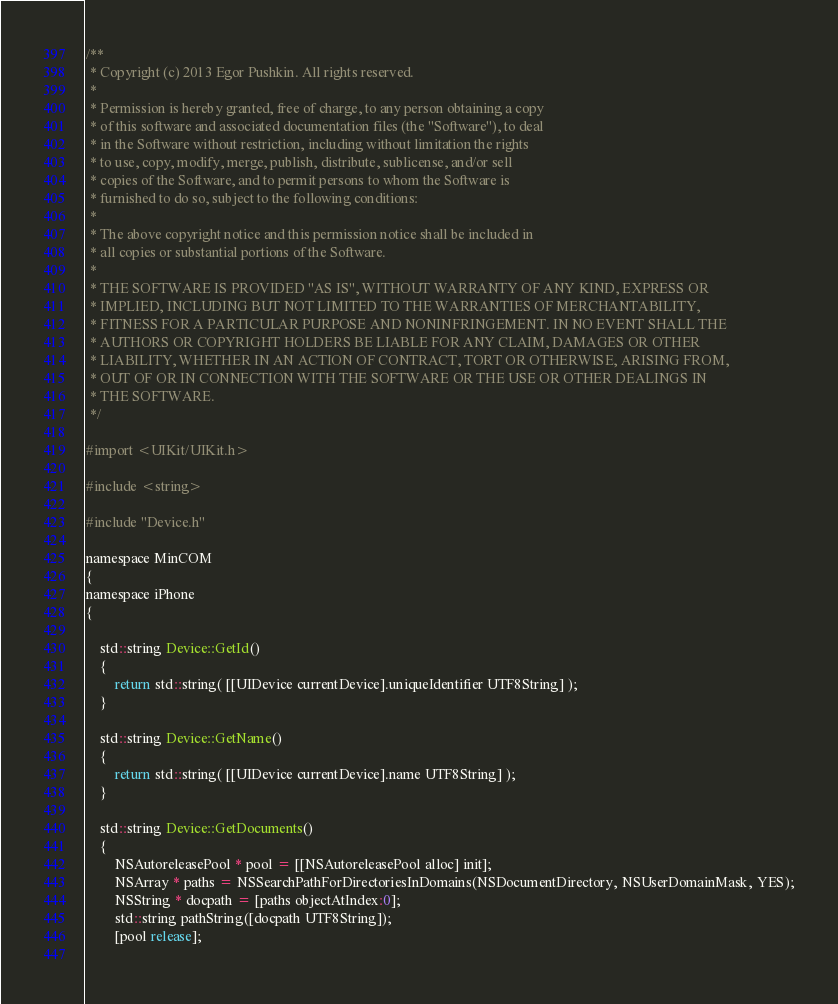Convert code to text. <code><loc_0><loc_0><loc_500><loc_500><_ObjectiveC_>/**
 * Copyright (c) 2013 Egor Pushkin. All rights reserved.
 * 
 * Permission is hereby granted, free of charge, to any person obtaining a copy
 * of this software and associated documentation files (the "Software"), to deal
 * in the Software without restriction, including without limitation the rights
 * to use, copy, modify, merge, publish, distribute, sublicense, and/or sell
 * copies of the Software, and to permit persons to whom the Software is
 * furnished to do so, subject to the following conditions:
 * 
 * The above copyright notice and this permission notice shall be included in
 * all copies or substantial portions of the Software.
 * 
 * THE SOFTWARE IS PROVIDED "AS IS", WITHOUT WARRANTY OF ANY KIND, EXPRESS OR
 * IMPLIED, INCLUDING BUT NOT LIMITED TO THE WARRANTIES OF MERCHANTABILITY,
 * FITNESS FOR A PARTICULAR PURPOSE AND NONINFRINGEMENT. IN NO EVENT SHALL THE
 * AUTHORS OR COPYRIGHT HOLDERS BE LIABLE FOR ANY CLAIM, DAMAGES OR OTHER
 * LIABILITY, WHETHER IN AN ACTION OF CONTRACT, TORT OR OTHERWISE, ARISING FROM,
 * OUT OF OR IN CONNECTION WITH THE SOFTWARE OR THE USE OR OTHER DEALINGS IN
 * THE SOFTWARE.
 */

#import <UIKit/UIKit.h>

#include <string>

#include "Device.h"

namespace MinCOM
{
namespace iPhone
{

    std::string Device::GetId()
    {
        return std::string( [[UIDevice currentDevice].uniqueIdentifier UTF8String] );
    }

    std::string Device::GetName()
    {
        return std::string( [[UIDevice currentDevice].name UTF8String] );        
    }
	
	std::string Device::GetDocuments()
	{
        NSAutoreleasePool * pool = [[NSAutoreleasePool alloc] init];		
        NSArray * paths = NSSearchPathForDirectoriesInDomains(NSDocumentDirectory, NSUserDomainMask, YES);
        NSString * docpath = [paths objectAtIndex:0];		
        std::string pathString([docpath UTF8String]);
        [pool release];	
		</code> 